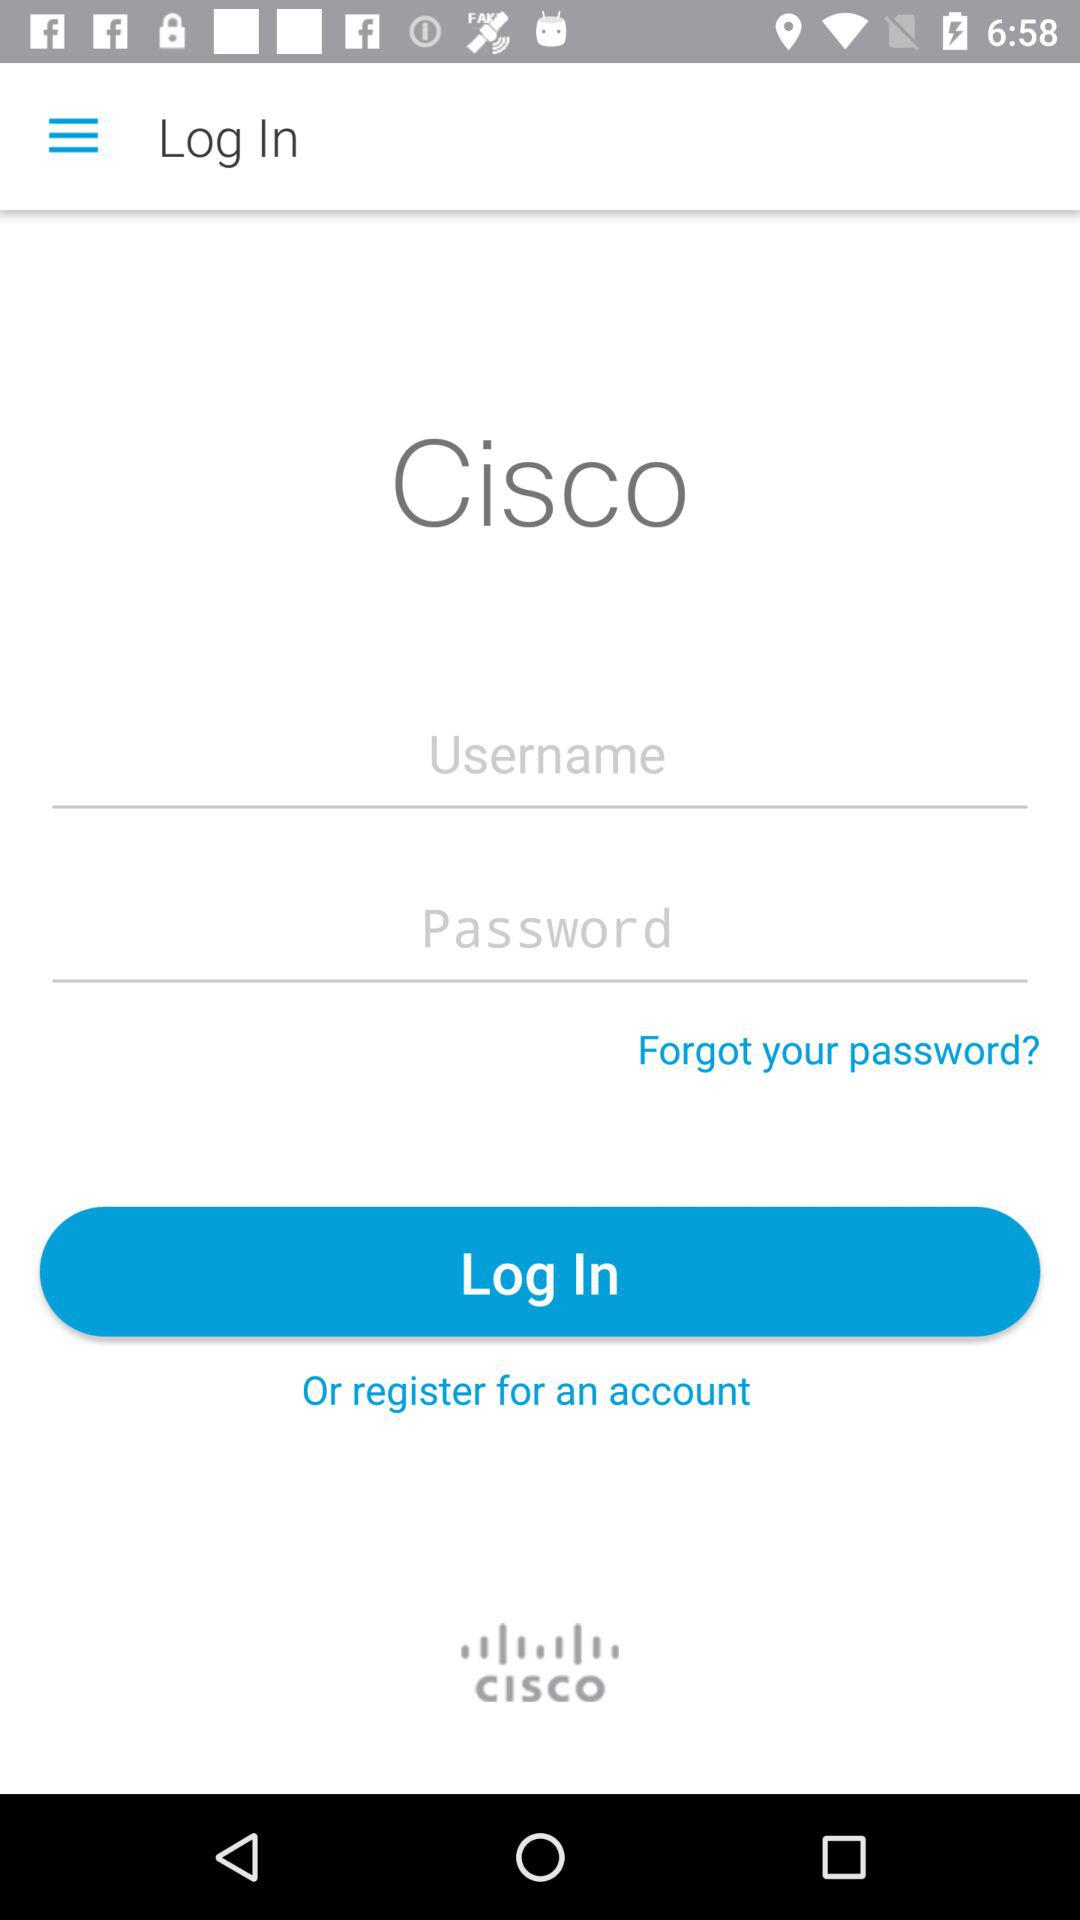What is the name of the application? The name of the application is "Cisco". 